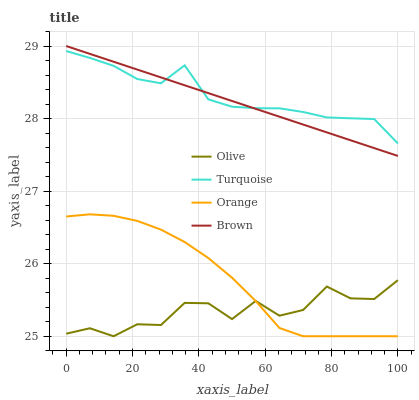Does Olive have the minimum area under the curve?
Answer yes or no. Yes. Does Turquoise have the maximum area under the curve?
Answer yes or no. Yes. Does Orange have the minimum area under the curve?
Answer yes or no. No. Does Orange have the maximum area under the curve?
Answer yes or no. No. Is Brown the smoothest?
Answer yes or no. Yes. Is Olive the roughest?
Answer yes or no. Yes. Is Orange the smoothest?
Answer yes or no. No. Is Orange the roughest?
Answer yes or no. No. Does Olive have the lowest value?
Answer yes or no. Yes. Does Turquoise have the lowest value?
Answer yes or no. No. Does Brown have the highest value?
Answer yes or no. Yes. Does Orange have the highest value?
Answer yes or no. No. Is Orange less than Brown?
Answer yes or no. Yes. Is Brown greater than Orange?
Answer yes or no. Yes. Does Orange intersect Olive?
Answer yes or no. Yes. Is Orange less than Olive?
Answer yes or no. No. Is Orange greater than Olive?
Answer yes or no. No. Does Orange intersect Brown?
Answer yes or no. No. 